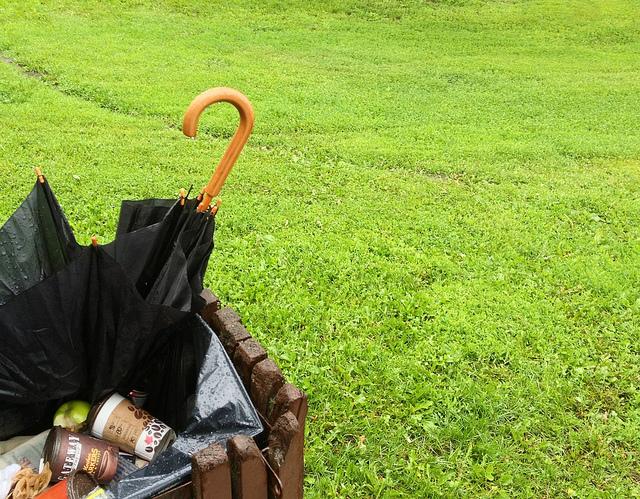To what does the handle in the trash belong?
Answer briefly. Umbrella. Where is the trash bin?
Keep it brief. In grass. How many cups of coffee are in the trash?
Short answer required. 3. 